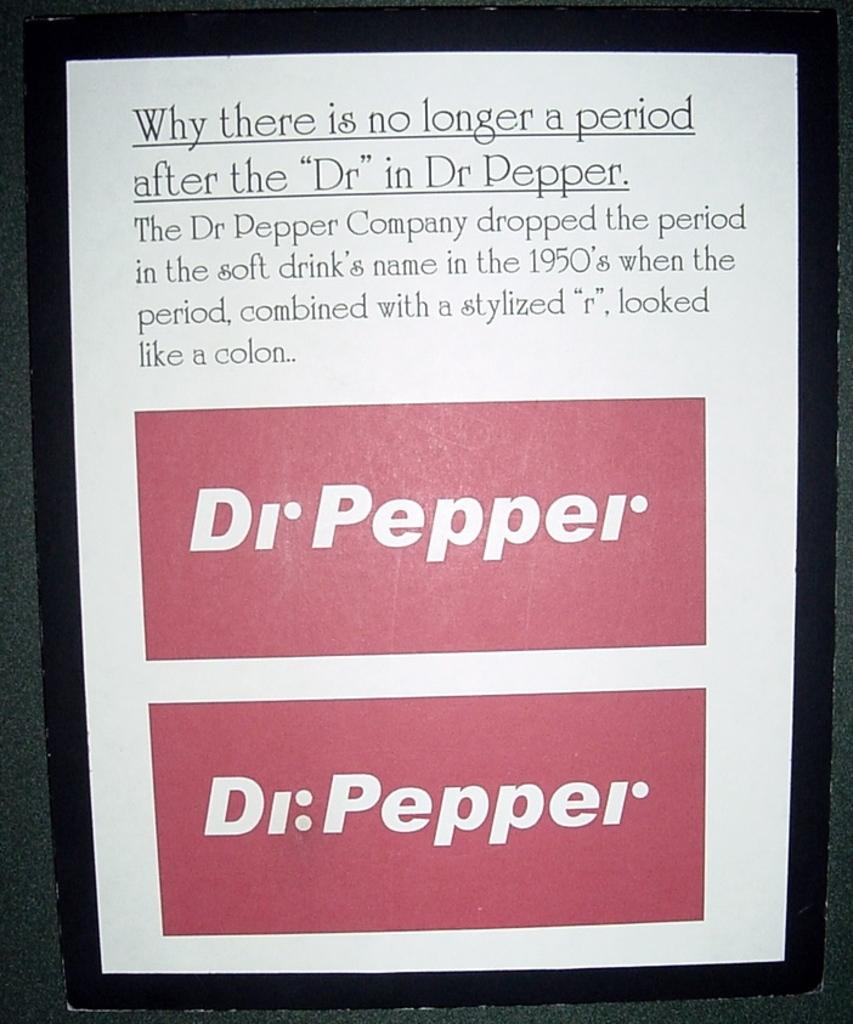<image>
Create a compact narrative representing the image presented. A poster explaining why there is not longer a period after the "Dr" in Dr Pepper 